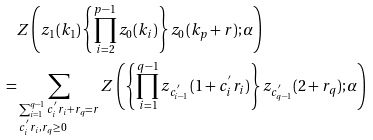<formula> <loc_0><loc_0><loc_500><loc_500>& Z \left ( z _ { 1 } ( k _ { 1 } ) \left \{ \prod _ { i = 2 } ^ { p - 1 } z _ { 0 } ( k _ { i } ) \right \} z _ { 0 } ( k _ { p } + r ) ; \alpha \right ) \\ = & \sum _ { \begin{subarray} { c } \sum _ { i = 1 } ^ { q - 1 } c ^ { ^ { \prime } } _ { i } r _ { i } + r _ { q } = r \\ c ^ { ^ { \prime } } _ { i } r _ { i } , r _ { q } \geq 0 \end{subarray} } Z \left ( \left \{ \prod _ { i = 1 } ^ { q - 1 } z _ { c ^ { ^ { \prime } } _ { i - 1 } } ( 1 + c ^ { ^ { \prime } } _ { i } r _ { i } ) \right \} z _ { c ^ { ^ { \prime } } _ { q - 1 } } ( 2 + r _ { q } ) ; \alpha \right )</formula> 